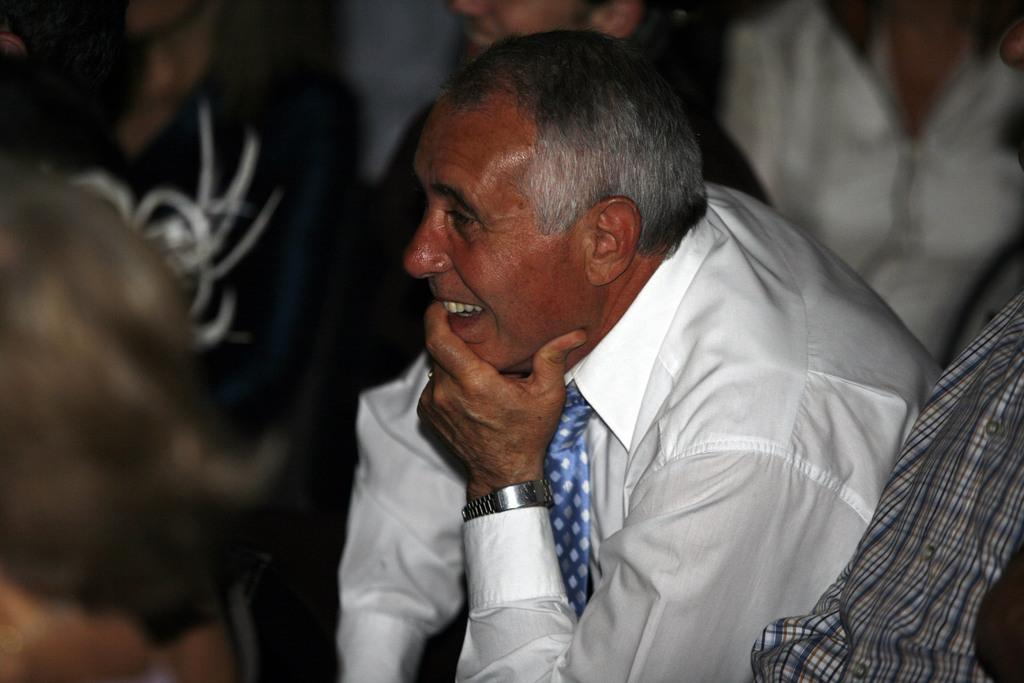What is the main subject of the image? There is a person sitting in the center of the image. How are the other people in the image positioned? There is a group of people sitting around the person in the center. What type of pear is being rung by the person in the image? There is no pear or bell present in the image; it only features a person sitting in the center and a group of people sitting around them. 